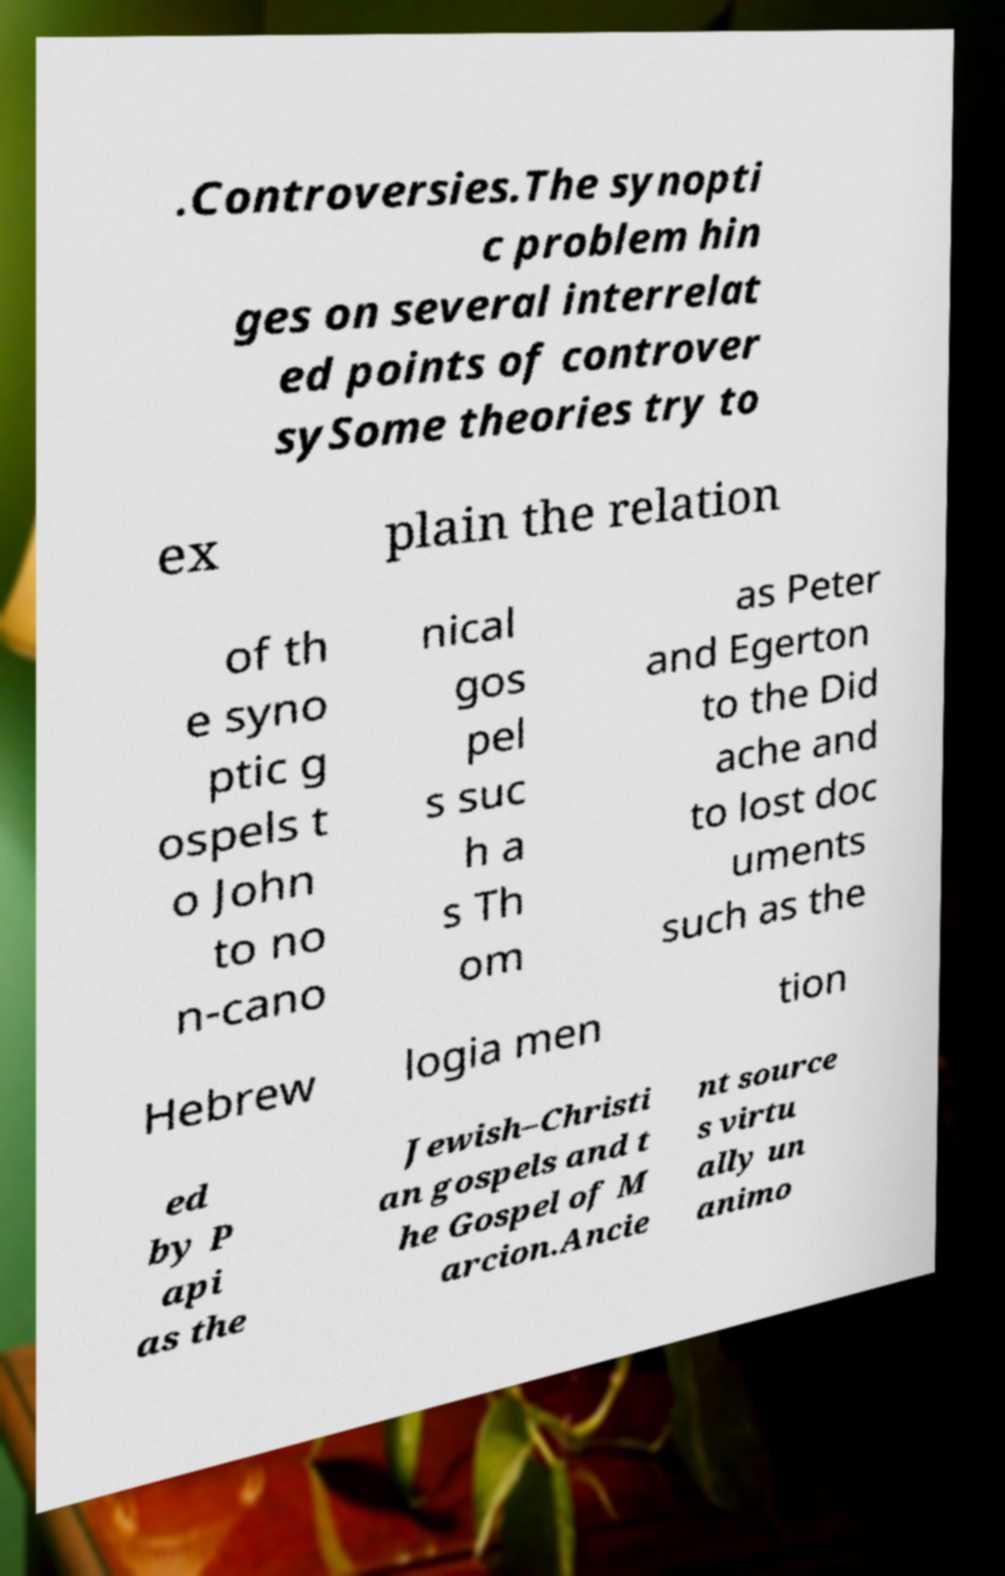Can you accurately transcribe the text from the provided image for me? .Controversies.The synopti c problem hin ges on several interrelat ed points of controver sySome theories try to ex plain the relation of th e syno ptic g ospels t o John to no n-cano nical gos pel s suc h a s Th om as Peter and Egerton to the Did ache and to lost doc uments such as the Hebrew logia men tion ed by P api as the Jewish–Christi an gospels and t he Gospel of M arcion.Ancie nt source s virtu ally un animo 